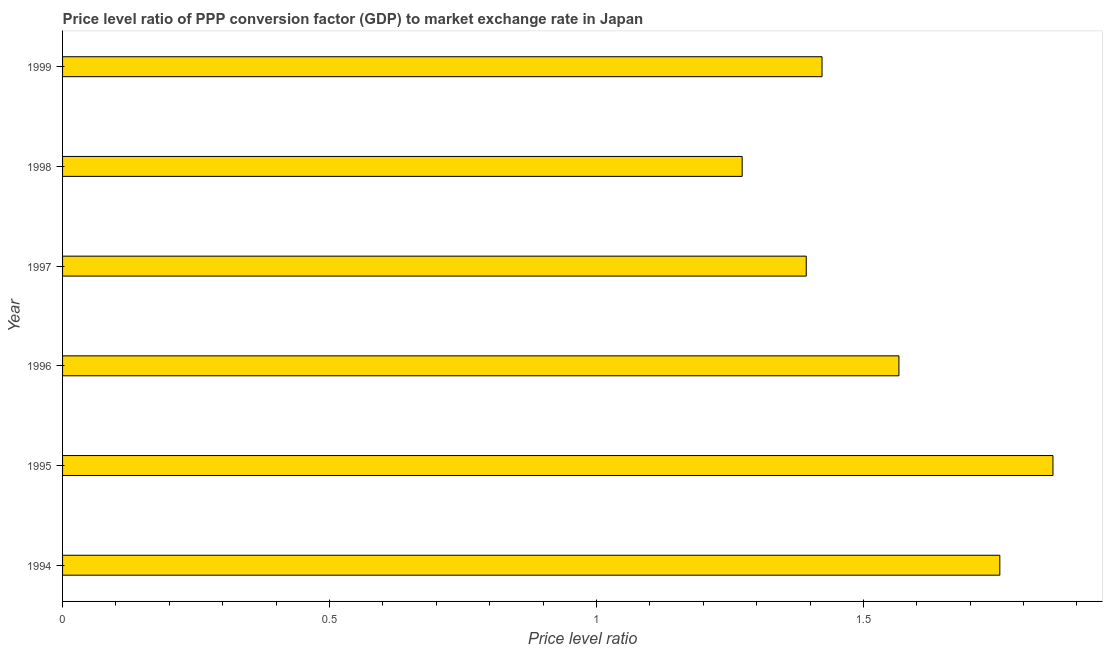What is the title of the graph?
Your response must be concise. Price level ratio of PPP conversion factor (GDP) to market exchange rate in Japan. What is the label or title of the X-axis?
Ensure brevity in your answer.  Price level ratio. What is the label or title of the Y-axis?
Provide a succinct answer. Year. What is the price level ratio in 1995?
Make the answer very short. 1.86. Across all years, what is the maximum price level ratio?
Give a very brief answer. 1.86. Across all years, what is the minimum price level ratio?
Make the answer very short. 1.27. In which year was the price level ratio maximum?
Make the answer very short. 1995. What is the sum of the price level ratio?
Your answer should be very brief. 9.27. What is the average price level ratio per year?
Offer a terse response. 1.54. What is the median price level ratio?
Offer a very short reply. 1.49. Is the difference between the price level ratio in 1994 and 1999 greater than the difference between any two years?
Provide a short and direct response. No. Is the sum of the price level ratio in 1995 and 1996 greater than the maximum price level ratio across all years?
Keep it short and to the point. Yes. What is the difference between the highest and the lowest price level ratio?
Make the answer very short. 0.58. How many bars are there?
Offer a very short reply. 6. How many years are there in the graph?
Ensure brevity in your answer.  6. What is the difference between two consecutive major ticks on the X-axis?
Offer a very short reply. 0.5. What is the Price level ratio in 1994?
Your answer should be compact. 1.76. What is the Price level ratio in 1995?
Ensure brevity in your answer.  1.86. What is the Price level ratio in 1996?
Provide a succinct answer. 1.57. What is the Price level ratio of 1997?
Keep it short and to the point. 1.39. What is the Price level ratio of 1998?
Make the answer very short. 1.27. What is the Price level ratio in 1999?
Keep it short and to the point. 1.42. What is the difference between the Price level ratio in 1994 and 1995?
Your answer should be very brief. -0.1. What is the difference between the Price level ratio in 1994 and 1996?
Your answer should be compact. 0.19. What is the difference between the Price level ratio in 1994 and 1997?
Ensure brevity in your answer.  0.36. What is the difference between the Price level ratio in 1994 and 1998?
Keep it short and to the point. 0.48. What is the difference between the Price level ratio in 1994 and 1999?
Offer a terse response. 0.33. What is the difference between the Price level ratio in 1995 and 1996?
Keep it short and to the point. 0.29. What is the difference between the Price level ratio in 1995 and 1997?
Ensure brevity in your answer.  0.46. What is the difference between the Price level ratio in 1995 and 1998?
Give a very brief answer. 0.58. What is the difference between the Price level ratio in 1995 and 1999?
Your response must be concise. 0.43. What is the difference between the Price level ratio in 1996 and 1997?
Offer a very short reply. 0.17. What is the difference between the Price level ratio in 1996 and 1998?
Your answer should be very brief. 0.29. What is the difference between the Price level ratio in 1996 and 1999?
Ensure brevity in your answer.  0.14. What is the difference between the Price level ratio in 1997 and 1998?
Provide a succinct answer. 0.12. What is the difference between the Price level ratio in 1997 and 1999?
Provide a succinct answer. -0.03. What is the difference between the Price level ratio in 1998 and 1999?
Provide a short and direct response. -0.15. What is the ratio of the Price level ratio in 1994 to that in 1995?
Offer a terse response. 0.95. What is the ratio of the Price level ratio in 1994 to that in 1996?
Give a very brief answer. 1.12. What is the ratio of the Price level ratio in 1994 to that in 1997?
Provide a succinct answer. 1.26. What is the ratio of the Price level ratio in 1994 to that in 1998?
Offer a very short reply. 1.38. What is the ratio of the Price level ratio in 1994 to that in 1999?
Keep it short and to the point. 1.23. What is the ratio of the Price level ratio in 1995 to that in 1996?
Ensure brevity in your answer.  1.18. What is the ratio of the Price level ratio in 1995 to that in 1997?
Keep it short and to the point. 1.33. What is the ratio of the Price level ratio in 1995 to that in 1998?
Offer a terse response. 1.46. What is the ratio of the Price level ratio in 1995 to that in 1999?
Your answer should be compact. 1.3. What is the ratio of the Price level ratio in 1996 to that in 1998?
Make the answer very short. 1.23. What is the ratio of the Price level ratio in 1996 to that in 1999?
Give a very brief answer. 1.1. What is the ratio of the Price level ratio in 1997 to that in 1998?
Provide a short and direct response. 1.09. What is the ratio of the Price level ratio in 1997 to that in 1999?
Offer a terse response. 0.98. What is the ratio of the Price level ratio in 1998 to that in 1999?
Offer a very short reply. 0.9. 